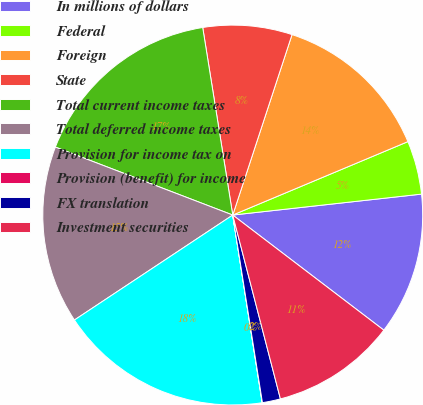Convert chart to OTSL. <chart><loc_0><loc_0><loc_500><loc_500><pie_chart><fcel>In millions of dollars<fcel>Federal<fcel>Foreign<fcel>State<fcel>Total current income taxes<fcel>Total deferred income taxes<fcel>Provision for income tax on<fcel>Provision (benefit) for income<fcel>FX translation<fcel>Investment securities<nl><fcel>12.12%<fcel>4.56%<fcel>13.63%<fcel>7.58%<fcel>16.65%<fcel>15.14%<fcel>18.16%<fcel>0.02%<fcel>1.54%<fcel>10.6%<nl></chart> 